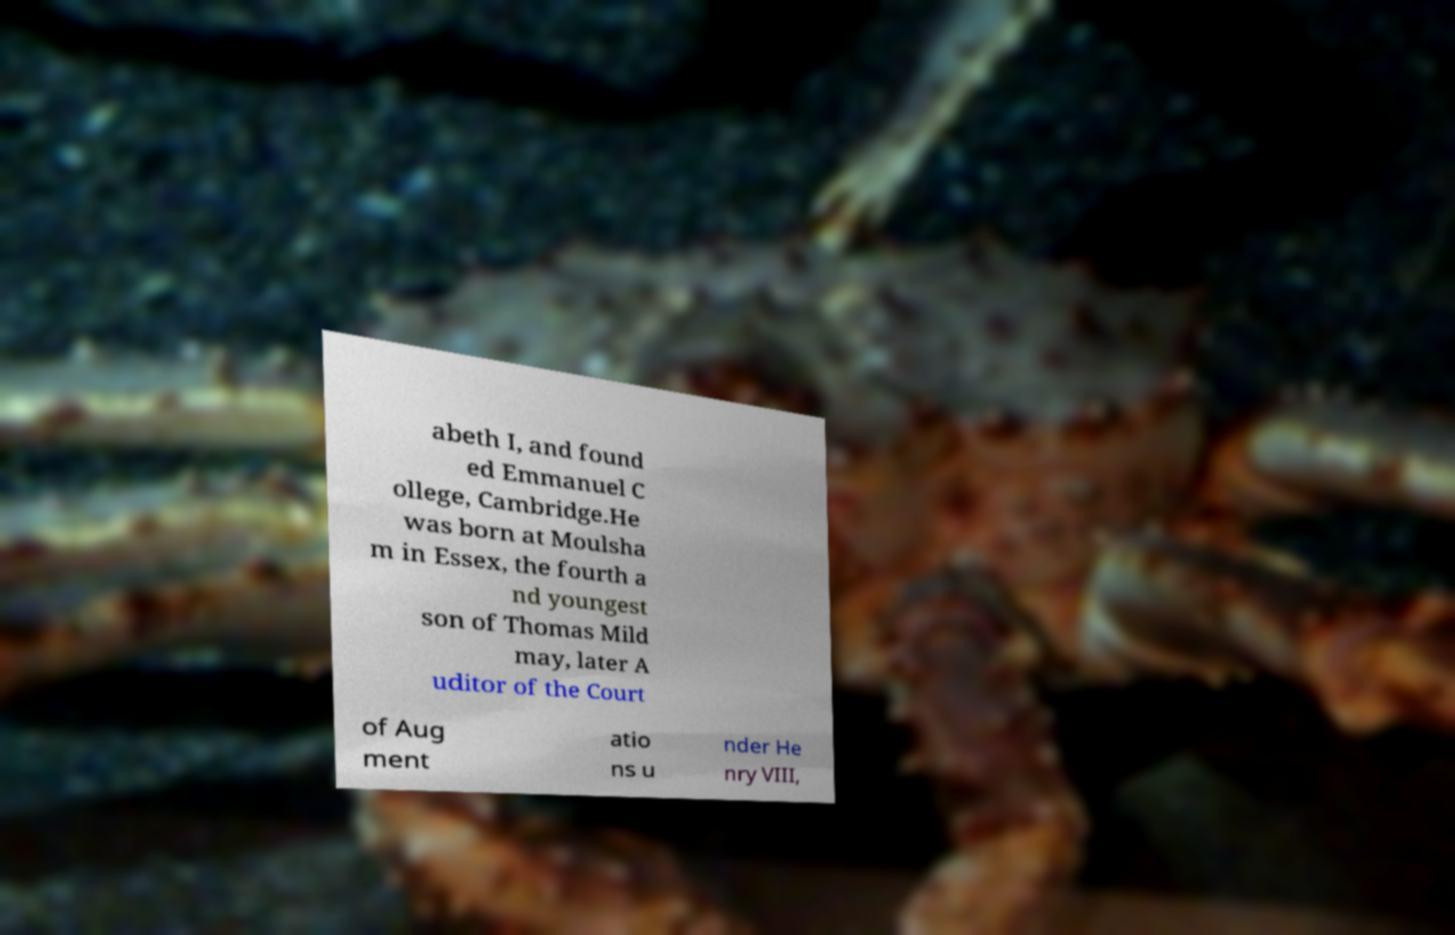Could you assist in decoding the text presented in this image and type it out clearly? abeth I, and found ed Emmanuel C ollege, Cambridge.He was born at Moulsha m in Essex, the fourth a nd youngest son of Thomas Mild may, later A uditor of the Court of Aug ment atio ns u nder He nry VIII, 